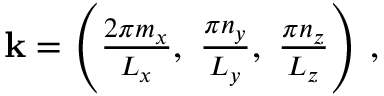<formula> <loc_0><loc_0><loc_500><loc_500>\begin{array} { r } { k = \left ( \frac { 2 \pi m _ { x } } { L _ { x } } , \, \frac { \pi n _ { y } } { L _ { y } } , \, \frac { \pi n _ { z } } { L _ { z } } \right ) \, , } \end{array}</formula> 